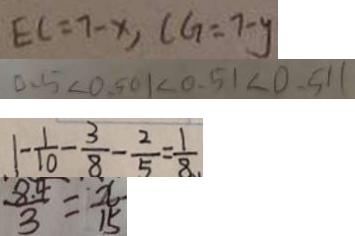Convert formula to latex. <formula><loc_0><loc_0><loc_500><loc_500>E C = 7 - x , C G = 7 - y 
 0 . 5 < 0 . 5 0 1 < 0 . 5 1 < 0 . 5 1 1 
 1 - \frac { 1 } { 1 0 } - \frac { 3 } { 8 } - \frac { 2 } { 5 } = \frac { 1 } { 8 } 
 \frac { 8 . 4 } { 3 } = \frac { x } { 1 5 }</formula> 